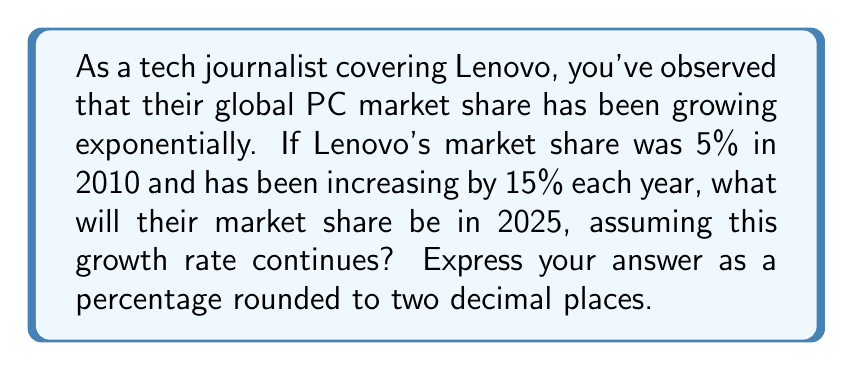Help me with this question. To solve this problem, we need to use the exponential growth formula:

$$A = P(1 + r)^t$$

Where:
$A$ = Final amount
$P$ = Initial amount (principal)
$r$ = Growth rate (as a decimal)
$t$ = Time period

Given:
$P = 5\%$ (initial market share in 2010)
$r = 15\% = 0.15$ (annual growth rate)
$t = 15$ years (from 2010 to 2025)

Let's plug these values into the formula:

$$A = 5\%(1 + 0.15)^{15}$$

Now, let's calculate step by step:

1) First, calculate $(1 + 0.15)^{15}$:
   $$(1.15)^{15} = 8.13709496$$

2) Multiply this by the initial market share:
   $$5\% \times 8.13709496 = 0.05 \times 8.13709496 = 0.406854748$$

3) Convert to a percentage:
   $$0.406854748 \times 100 = 40.6854748\%$$

4) Round to two decimal places:
   $$40.69\%$$
Answer: $40.69\%$ 